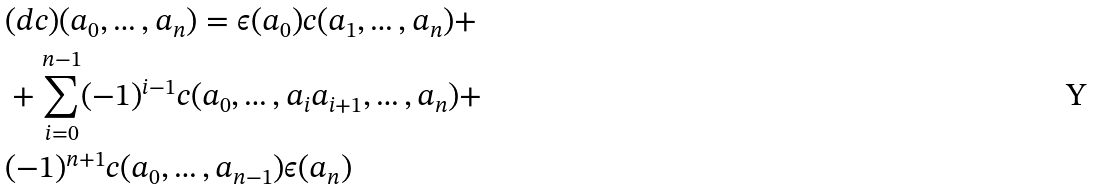Convert formula to latex. <formula><loc_0><loc_0><loc_500><loc_500>& ( d c ) ( a _ { 0 } , \dots , a _ { n } ) = \epsilon ( a _ { 0 } ) c ( a _ { 1 } , \dots , a _ { n } ) + \\ & + \sum _ { i = 0 } ^ { n - 1 } ( - 1 ) ^ { i - 1 } c ( a _ { 0 } , \dots , a _ { i } a _ { i + 1 } , \dots , a _ { n } ) + \\ & ( - 1 ) ^ { n + 1 } c ( a _ { 0 } , \dots , a _ { n - 1 } ) \epsilon ( a _ { n } )</formula> 